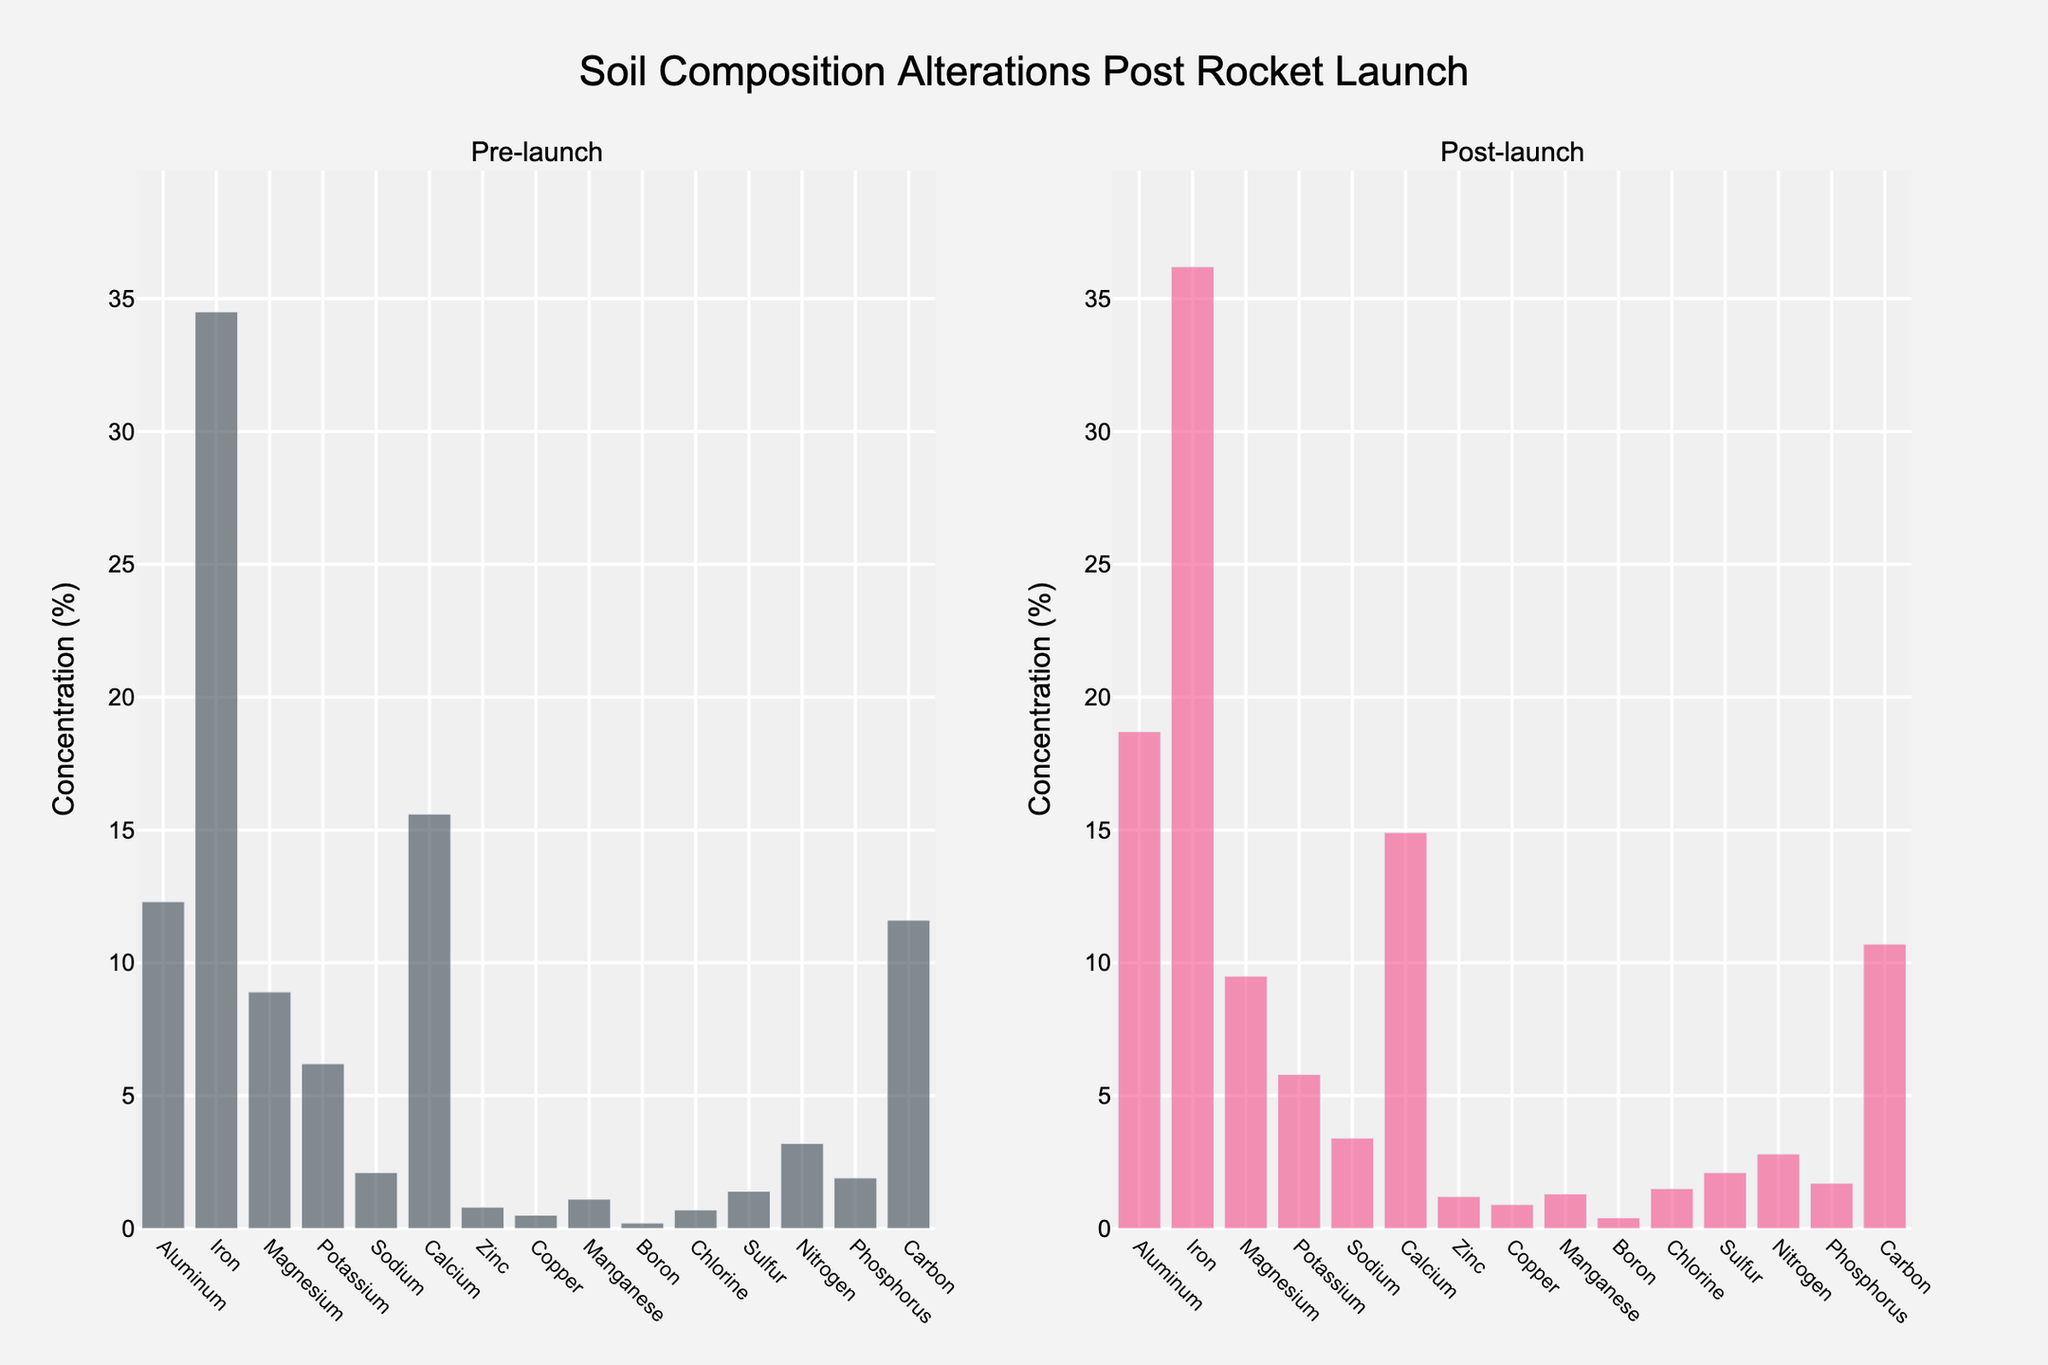What chemical element shows the most significant increase in concentration after the launch? To identify the element with the most significant increase, compare the differences between the pre-launch and post-launch concentrations for each element. The largest increase is found for Aluminum (18.7 - 12.3 = 6.4).
Answer: Aluminum Which element has a lower concentration post-launch compared to pre-launch? Compare the pre-launch and post-launch values for each element. Potassium (6.2 to 5.8), Calcium (15.6 to 14.9), Nitrogen (3.2 to 2.8), and Phosphorus (1.9 to 1.7) show decreased concentrations post-launch.
Answer: Potassium, Calcium, Nitrogen, Phosphorus What is the total concentration of Iron and Magnesium pre-launch? Add the pre-launch concentrations of Iron and Magnesium: 34.5 (Iron) + 8.9 (Magnesium) = 43.4.
Answer: 43.4 How much did the concentration of Chlorine increase post-launch? Calculate the difference between the post-launch and pre-launch values for Chlorine: 1.5 - 0.7 = 0.8.
Answer: 0.8 Which element has the smallest change in concentration post-launch? Determine the difference between the pre-launch and post-launch values for each element. Magnesium has the smallest change, increasing from 8.9 to 9.5, a difference of 0.6.
Answer: Magnesium Is Sulfur concentration higher or lower post-launch compared to pre-launch? Compare the pre-launch and post-launch values for Sulfur. Post-launch Sulfur is 2.1 compared to 1.4 pre-launch, so it is higher.
Answer: Higher What is the average concentration of Sodium and Zinc post-launch? Calculate the average of post-launch concentrations for Sodium (3.4) and Zinc (1.2): (3.4 + 1.2) / 2 = 2.3.
Answer: 2.3 Which element's concentration is closest to 10% post-launch? Look at the post-launch concentrations and find the one closest to 10%. Carbon's concentration is 10.7%, which is the closest to 10%.
Answer: Carbon Compare the visual lengths of the bars for Aluminum pre-launch and post-launch. Which bar is taller? Visually assess the bar heights for Aluminum; the post-launch bar (18.7) is taller than the pre-launch bar (12.3).
Answer: Post-launch Is there any element whose concentration remained the same post-launch? Check if any elements have identical pre-launch and post-launch concentrations. No element's concentration remained the same.
Answer: No 